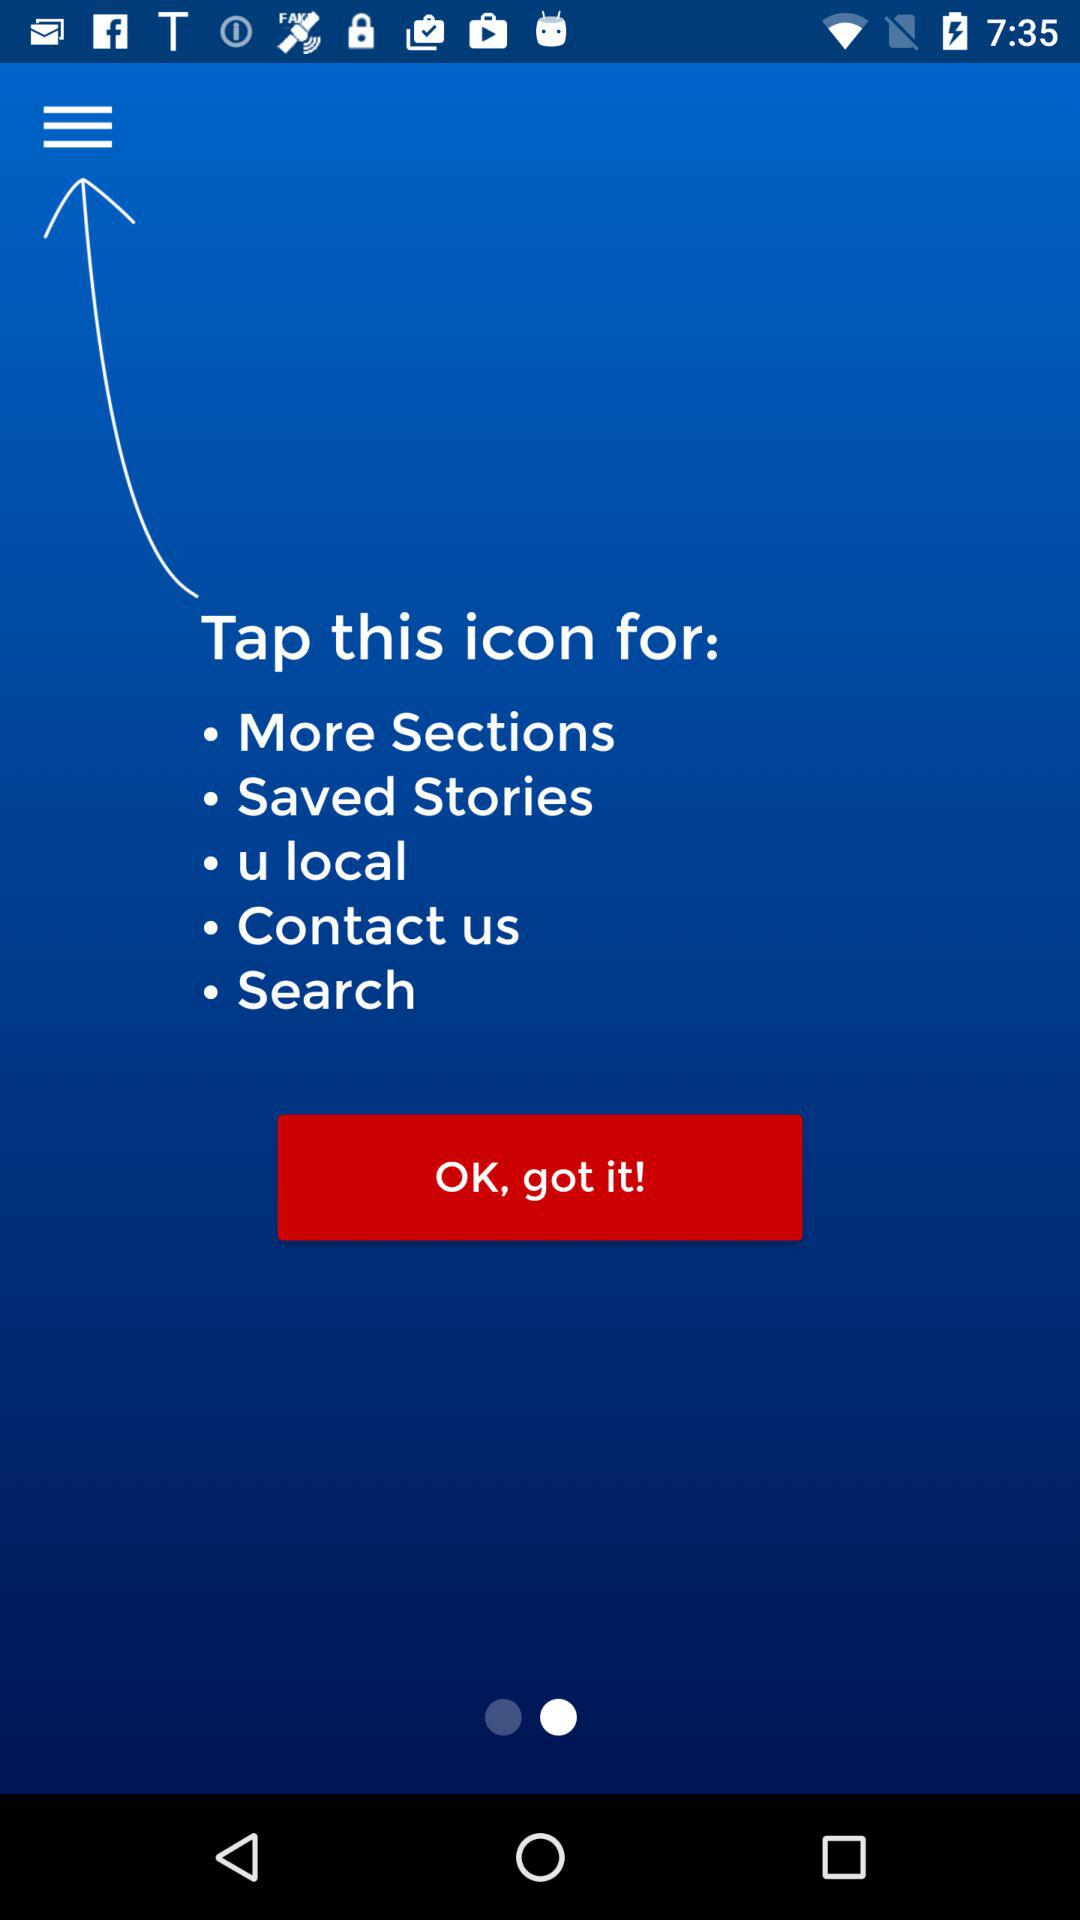How many sections are there in total?
Answer the question using a single word or phrase. 5 